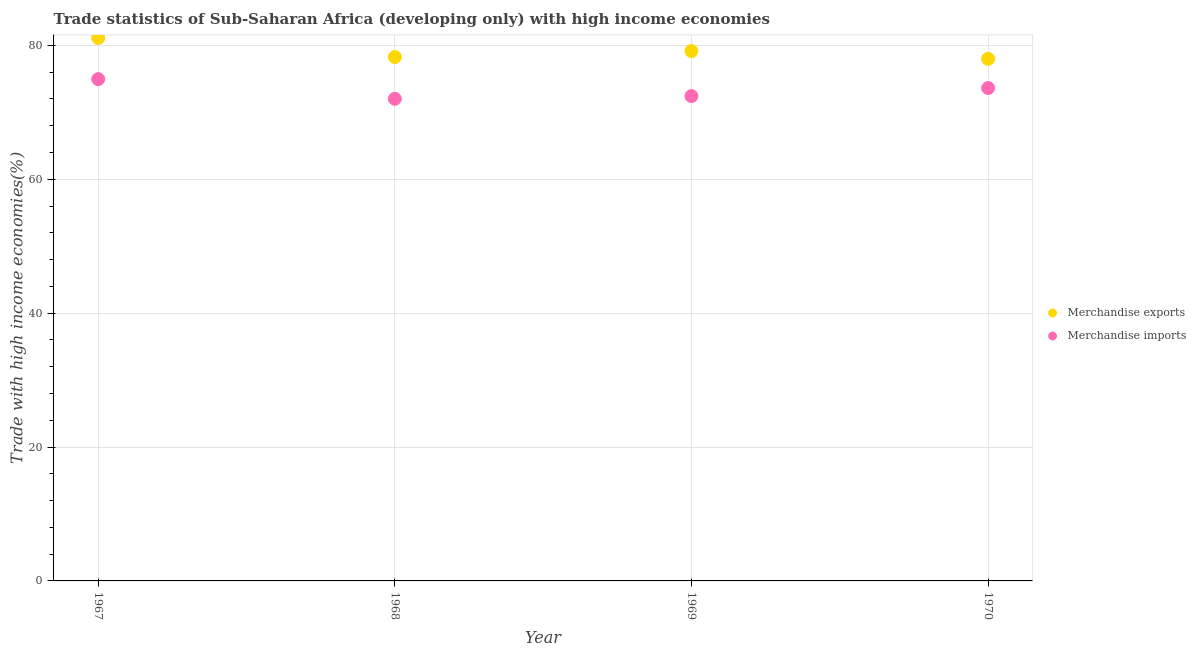Is the number of dotlines equal to the number of legend labels?
Your answer should be very brief. Yes. What is the merchandise imports in 1969?
Provide a short and direct response. 72.43. Across all years, what is the maximum merchandise exports?
Provide a succinct answer. 81.13. Across all years, what is the minimum merchandise imports?
Offer a terse response. 72.03. In which year was the merchandise imports maximum?
Provide a short and direct response. 1967. In which year was the merchandise imports minimum?
Provide a short and direct response. 1968. What is the total merchandise imports in the graph?
Offer a very short reply. 293.06. What is the difference between the merchandise exports in 1967 and that in 1969?
Your answer should be compact. 1.97. What is the difference between the merchandise imports in 1969 and the merchandise exports in 1967?
Offer a very short reply. -8.69. What is the average merchandise imports per year?
Your response must be concise. 73.27. In the year 1969, what is the difference between the merchandise imports and merchandise exports?
Keep it short and to the point. -6.73. In how many years, is the merchandise exports greater than 72 %?
Make the answer very short. 4. What is the ratio of the merchandise exports in 1967 to that in 1968?
Your response must be concise. 1.04. Is the difference between the merchandise imports in 1968 and 1969 greater than the difference between the merchandise exports in 1968 and 1969?
Provide a short and direct response. Yes. What is the difference between the highest and the second highest merchandise imports?
Keep it short and to the point. 1.33. What is the difference between the highest and the lowest merchandise exports?
Your answer should be very brief. 3.12. Is the sum of the merchandise exports in 1967 and 1969 greater than the maximum merchandise imports across all years?
Give a very brief answer. Yes. Does the merchandise exports monotonically increase over the years?
Offer a very short reply. No. Is the merchandise imports strictly greater than the merchandise exports over the years?
Ensure brevity in your answer.  No. Is the merchandise imports strictly less than the merchandise exports over the years?
Offer a very short reply. Yes. How many dotlines are there?
Your response must be concise. 2. What is the difference between two consecutive major ticks on the Y-axis?
Your answer should be compact. 20. Are the values on the major ticks of Y-axis written in scientific E-notation?
Your answer should be compact. No. Where does the legend appear in the graph?
Your answer should be very brief. Center right. How many legend labels are there?
Provide a succinct answer. 2. How are the legend labels stacked?
Your response must be concise. Vertical. What is the title of the graph?
Your answer should be very brief. Trade statistics of Sub-Saharan Africa (developing only) with high income economies. What is the label or title of the X-axis?
Provide a short and direct response. Year. What is the label or title of the Y-axis?
Provide a short and direct response. Trade with high income economies(%). What is the Trade with high income economies(%) of Merchandise exports in 1967?
Your answer should be very brief. 81.13. What is the Trade with high income economies(%) of Merchandise imports in 1967?
Provide a succinct answer. 74.96. What is the Trade with high income economies(%) of Merchandise exports in 1968?
Make the answer very short. 78.27. What is the Trade with high income economies(%) of Merchandise imports in 1968?
Make the answer very short. 72.03. What is the Trade with high income economies(%) in Merchandise exports in 1969?
Your answer should be compact. 79.16. What is the Trade with high income economies(%) of Merchandise imports in 1969?
Offer a terse response. 72.43. What is the Trade with high income economies(%) of Merchandise exports in 1970?
Give a very brief answer. 78. What is the Trade with high income economies(%) of Merchandise imports in 1970?
Your response must be concise. 73.64. Across all years, what is the maximum Trade with high income economies(%) in Merchandise exports?
Provide a succinct answer. 81.13. Across all years, what is the maximum Trade with high income economies(%) in Merchandise imports?
Provide a short and direct response. 74.96. Across all years, what is the minimum Trade with high income economies(%) of Merchandise exports?
Your response must be concise. 78. Across all years, what is the minimum Trade with high income economies(%) of Merchandise imports?
Your response must be concise. 72.03. What is the total Trade with high income economies(%) in Merchandise exports in the graph?
Provide a succinct answer. 316.56. What is the total Trade with high income economies(%) in Merchandise imports in the graph?
Make the answer very short. 293.06. What is the difference between the Trade with high income economies(%) of Merchandise exports in 1967 and that in 1968?
Provide a short and direct response. 2.85. What is the difference between the Trade with high income economies(%) of Merchandise imports in 1967 and that in 1968?
Your response must be concise. 2.93. What is the difference between the Trade with high income economies(%) of Merchandise exports in 1967 and that in 1969?
Give a very brief answer. 1.97. What is the difference between the Trade with high income economies(%) in Merchandise imports in 1967 and that in 1969?
Give a very brief answer. 2.53. What is the difference between the Trade with high income economies(%) of Merchandise exports in 1967 and that in 1970?
Provide a short and direct response. 3.12. What is the difference between the Trade with high income economies(%) of Merchandise imports in 1967 and that in 1970?
Make the answer very short. 1.33. What is the difference between the Trade with high income economies(%) in Merchandise exports in 1968 and that in 1969?
Give a very brief answer. -0.89. What is the difference between the Trade with high income economies(%) of Merchandise imports in 1968 and that in 1969?
Provide a short and direct response. -0.4. What is the difference between the Trade with high income economies(%) of Merchandise exports in 1968 and that in 1970?
Your answer should be very brief. 0.27. What is the difference between the Trade with high income economies(%) of Merchandise imports in 1968 and that in 1970?
Your answer should be compact. -1.61. What is the difference between the Trade with high income economies(%) of Merchandise exports in 1969 and that in 1970?
Your answer should be compact. 1.16. What is the difference between the Trade with high income economies(%) in Merchandise imports in 1969 and that in 1970?
Your answer should be very brief. -1.2. What is the difference between the Trade with high income economies(%) in Merchandise exports in 1967 and the Trade with high income economies(%) in Merchandise imports in 1968?
Make the answer very short. 9.1. What is the difference between the Trade with high income economies(%) in Merchandise exports in 1967 and the Trade with high income economies(%) in Merchandise imports in 1969?
Give a very brief answer. 8.69. What is the difference between the Trade with high income economies(%) of Merchandise exports in 1967 and the Trade with high income economies(%) of Merchandise imports in 1970?
Ensure brevity in your answer.  7.49. What is the difference between the Trade with high income economies(%) in Merchandise exports in 1968 and the Trade with high income economies(%) in Merchandise imports in 1969?
Make the answer very short. 5.84. What is the difference between the Trade with high income economies(%) of Merchandise exports in 1968 and the Trade with high income economies(%) of Merchandise imports in 1970?
Your answer should be compact. 4.63. What is the difference between the Trade with high income economies(%) of Merchandise exports in 1969 and the Trade with high income economies(%) of Merchandise imports in 1970?
Make the answer very short. 5.52. What is the average Trade with high income economies(%) in Merchandise exports per year?
Ensure brevity in your answer.  79.14. What is the average Trade with high income economies(%) of Merchandise imports per year?
Your response must be concise. 73.27. In the year 1967, what is the difference between the Trade with high income economies(%) of Merchandise exports and Trade with high income economies(%) of Merchandise imports?
Offer a very short reply. 6.16. In the year 1968, what is the difference between the Trade with high income economies(%) in Merchandise exports and Trade with high income economies(%) in Merchandise imports?
Offer a terse response. 6.24. In the year 1969, what is the difference between the Trade with high income economies(%) in Merchandise exports and Trade with high income economies(%) in Merchandise imports?
Your answer should be very brief. 6.73. In the year 1970, what is the difference between the Trade with high income economies(%) in Merchandise exports and Trade with high income economies(%) in Merchandise imports?
Ensure brevity in your answer.  4.37. What is the ratio of the Trade with high income economies(%) of Merchandise exports in 1967 to that in 1968?
Offer a terse response. 1.04. What is the ratio of the Trade with high income economies(%) in Merchandise imports in 1967 to that in 1968?
Provide a short and direct response. 1.04. What is the ratio of the Trade with high income economies(%) of Merchandise exports in 1967 to that in 1969?
Give a very brief answer. 1.02. What is the ratio of the Trade with high income economies(%) of Merchandise imports in 1967 to that in 1969?
Make the answer very short. 1.03. What is the ratio of the Trade with high income economies(%) of Merchandise imports in 1967 to that in 1970?
Offer a very short reply. 1.02. What is the ratio of the Trade with high income economies(%) in Merchandise exports in 1968 to that in 1969?
Your response must be concise. 0.99. What is the ratio of the Trade with high income economies(%) in Merchandise imports in 1968 to that in 1969?
Give a very brief answer. 0.99. What is the ratio of the Trade with high income economies(%) of Merchandise exports in 1968 to that in 1970?
Provide a short and direct response. 1. What is the ratio of the Trade with high income economies(%) in Merchandise imports in 1968 to that in 1970?
Your answer should be very brief. 0.98. What is the ratio of the Trade with high income economies(%) of Merchandise exports in 1969 to that in 1970?
Ensure brevity in your answer.  1.01. What is the ratio of the Trade with high income economies(%) of Merchandise imports in 1969 to that in 1970?
Make the answer very short. 0.98. What is the difference between the highest and the second highest Trade with high income economies(%) in Merchandise exports?
Your answer should be very brief. 1.97. What is the difference between the highest and the second highest Trade with high income economies(%) in Merchandise imports?
Keep it short and to the point. 1.33. What is the difference between the highest and the lowest Trade with high income economies(%) of Merchandise exports?
Provide a succinct answer. 3.12. What is the difference between the highest and the lowest Trade with high income economies(%) of Merchandise imports?
Provide a succinct answer. 2.93. 